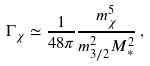Convert formula to latex. <formula><loc_0><loc_0><loc_500><loc_500>\Gamma _ { \chi } \simeq \frac { 1 } { 4 8 \pi } \frac { m _ { \chi } ^ { 5 } } { m _ { 3 / 2 } ^ { 2 } M _ { * } ^ { 2 } } \, ,</formula> 